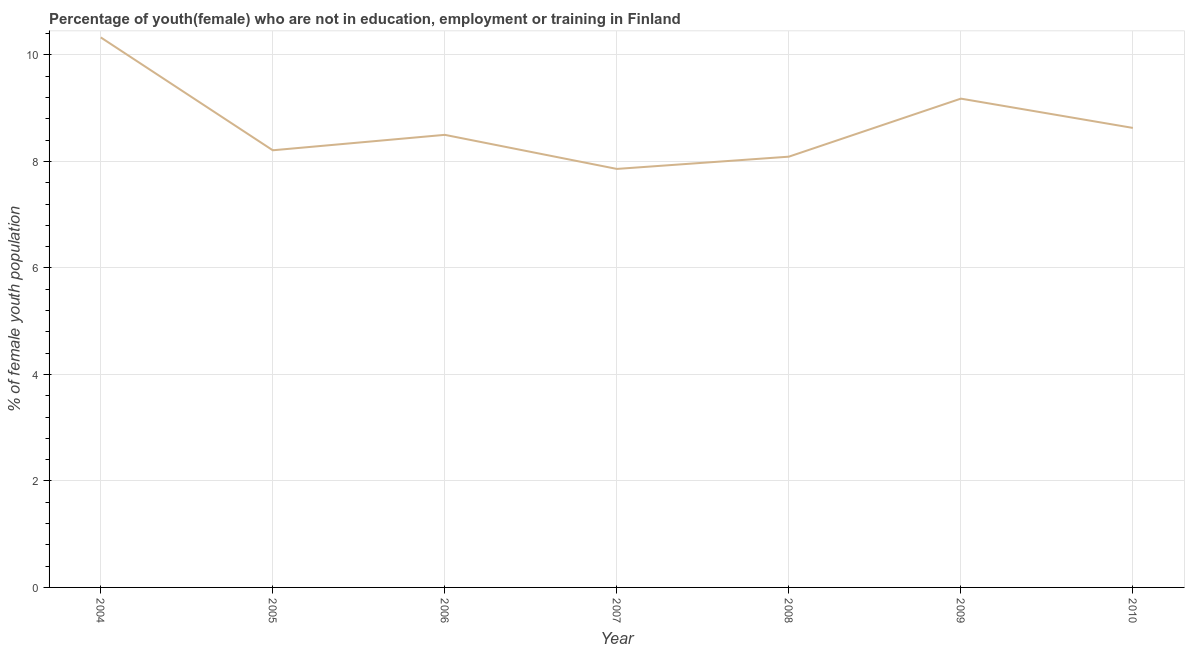What is the unemployed female youth population in 2007?
Offer a terse response. 7.86. Across all years, what is the maximum unemployed female youth population?
Your answer should be very brief. 10.33. Across all years, what is the minimum unemployed female youth population?
Your answer should be compact. 7.86. In which year was the unemployed female youth population maximum?
Offer a very short reply. 2004. In which year was the unemployed female youth population minimum?
Offer a terse response. 2007. What is the sum of the unemployed female youth population?
Your answer should be very brief. 60.8. What is the difference between the unemployed female youth population in 2006 and 2009?
Keep it short and to the point. -0.68. What is the average unemployed female youth population per year?
Your answer should be compact. 8.69. What is the median unemployed female youth population?
Offer a terse response. 8.5. What is the ratio of the unemployed female youth population in 2004 to that in 2010?
Provide a short and direct response. 1.2. Is the difference between the unemployed female youth population in 2006 and 2007 greater than the difference between any two years?
Offer a very short reply. No. What is the difference between the highest and the second highest unemployed female youth population?
Give a very brief answer. 1.15. Is the sum of the unemployed female youth population in 2006 and 2008 greater than the maximum unemployed female youth population across all years?
Your answer should be very brief. Yes. What is the difference between the highest and the lowest unemployed female youth population?
Keep it short and to the point. 2.47. Does the unemployed female youth population monotonically increase over the years?
Make the answer very short. No. How many years are there in the graph?
Provide a short and direct response. 7. What is the title of the graph?
Your answer should be compact. Percentage of youth(female) who are not in education, employment or training in Finland. What is the label or title of the X-axis?
Your answer should be very brief. Year. What is the label or title of the Y-axis?
Make the answer very short. % of female youth population. What is the % of female youth population of 2004?
Give a very brief answer. 10.33. What is the % of female youth population of 2005?
Give a very brief answer. 8.21. What is the % of female youth population of 2006?
Your response must be concise. 8.5. What is the % of female youth population of 2007?
Provide a short and direct response. 7.86. What is the % of female youth population in 2008?
Provide a short and direct response. 8.09. What is the % of female youth population in 2009?
Offer a terse response. 9.18. What is the % of female youth population in 2010?
Your answer should be compact. 8.63. What is the difference between the % of female youth population in 2004 and 2005?
Give a very brief answer. 2.12. What is the difference between the % of female youth population in 2004 and 2006?
Your answer should be compact. 1.83. What is the difference between the % of female youth population in 2004 and 2007?
Provide a succinct answer. 2.47. What is the difference between the % of female youth population in 2004 and 2008?
Provide a short and direct response. 2.24. What is the difference between the % of female youth population in 2004 and 2009?
Your response must be concise. 1.15. What is the difference between the % of female youth population in 2005 and 2006?
Ensure brevity in your answer.  -0.29. What is the difference between the % of female youth population in 2005 and 2007?
Your response must be concise. 0.35. What is the difference between the % of female youth population in 2005 and 2008?
Provide a succinct answer. 0.12. What is the difference between the % of female youth population in 2005 and 2009?
Keep it short and to the point. -0.97. What is the difference between the % of female youth population in 2005 and 2010?
Provide a succinct answer. -0.42. What is the difference between the % of female youth population in 2006 and 2007?
Make the answer very short. 0.64. What is the difference between the % of female youth population in 2006 and 2008?
Give a very brief answer. 0.41. What is the difference between the % of female youth population in 2006 and 2009?
Make the answer very short. -0.68. What is the difference between the % of female youth population in 2006 and 2010?
Your answer should be compact. -0.13. What is the difference between the % of female youth population in 2007 and 2008?
Your answer should be very brief. -0.23. What is the difference between the % of female youth population in 2007 and 2009?
Offer a terse response. -1.32. What is the difference between the % of female youth population in 2007 and 2010?
Keep it short and to the point. -0.77. What is the difference between the % of female youth population in 2008 and 2009?
Provide a short and direct response. -1.09. What is the difference between the % of female youth population in 2008 and 2010?
Your response must be concise. -0.54. What is the difference between the % of female youth population in 2009 and 2010?
Provide a succinct answer. 0.55. What is the ratio of the % of female youth population in 2004 to that in 2005?
Make the answer very short. 1.26. What is the ratio of the % of female youth population in 2004 to that in 2006?
Keep it short and to the point. 1.22. What is the ratio of the % of female youth population in 2004 to that in 2007?
Provide a succinct answer. 1.31. What is the ratio of the % of female youth population in 2004 to that in 2008?
Ensure brevity in your answer.  1.28. What is the ratio of the % of female youth population in 2004 to that in 2009?
Keep it short and to the point. 1.12. What is the ratio of the % of female youth population in 2004 to that in 2010?
Provide a succinct answer. 1.2. What is the ratio of the % of female youth population in 2005 to that in 2006?
Keep it short and to the point. 0.97. What is the ratio of the % of female youth population in 2005 to that in 2007?
Offer a terse response. 1.04. What is the ratio of the % of female youth population in 2005 to that in 2009?
Provide a succinct answer. 0.89. What is the ratio of the % of female youth population in 2005 to that in 2010?
Make the answer very short. 0.95. What is the ratio of the % of female youth population in 2006 to that in 2007?
Provide a succinct answer. 1.08. What is the ratio of the % of female youth population in 2006 to that in 2008?
Offer a terse response. 1.05. What is the ratio of the % of female youth population in 2006 to that in 2009?
Provide a short and direct response. 0.93. What is the ratio of the % of female youth population in 2007 to that in 2009?
Keep it short and to the point. 0.86. What is the ratio of the % of female youth population in 2007 to that in 2010?
Provide a short and direct response. 0.91. What is the ratio of the % of female youth population in 2008 to that in 2009?
Offer a very short reply. 0.88. What is the ratio of the % of female youth population in 2008 to that in 2010?
Offer a terse response. 0.94. What is the ratio of the % of female youth population in 2009 to that in 2010?
Provide a succinct answer. 1.06. 